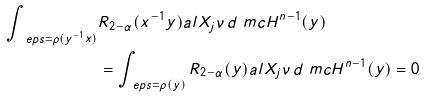Convert formula to latex. <formula><loc_0><loc_0><loc_500><loc_500>\int _ { \ e p s = \rho ( y ^ { - 1 } x ) } & R _ { 2 - \alpha } ( x ^ { - 1 } y ) a l { X _ { j } } { \nu } \, d \ m c H ^ { n - 1 } ( y ) \\ & = \int _ { \ e p s = \rho ( y ) } R _ { 2 - \alpha } ( y ) a l { X _ { j } } { \nu } \, d \ m c H ^ { n - 1 } ( y ) = 0</formula> 